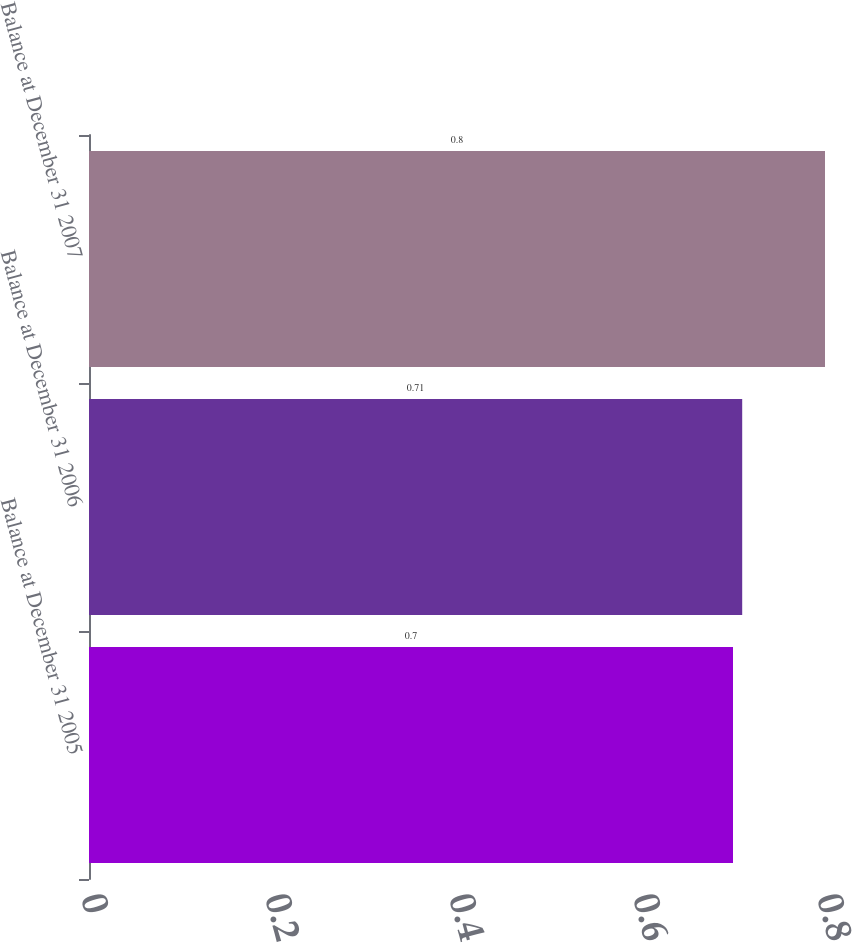<chart> <loc_0><loc_0><loc_500><loc_500><bar_chart><fcel>Balance at December 31 2005<fcel>Balance at December 31 2006<fcel>Balance at December 31 2007<nl><fcel>0.7<fcel>0.71<fcel>0.8<nl></chart> 